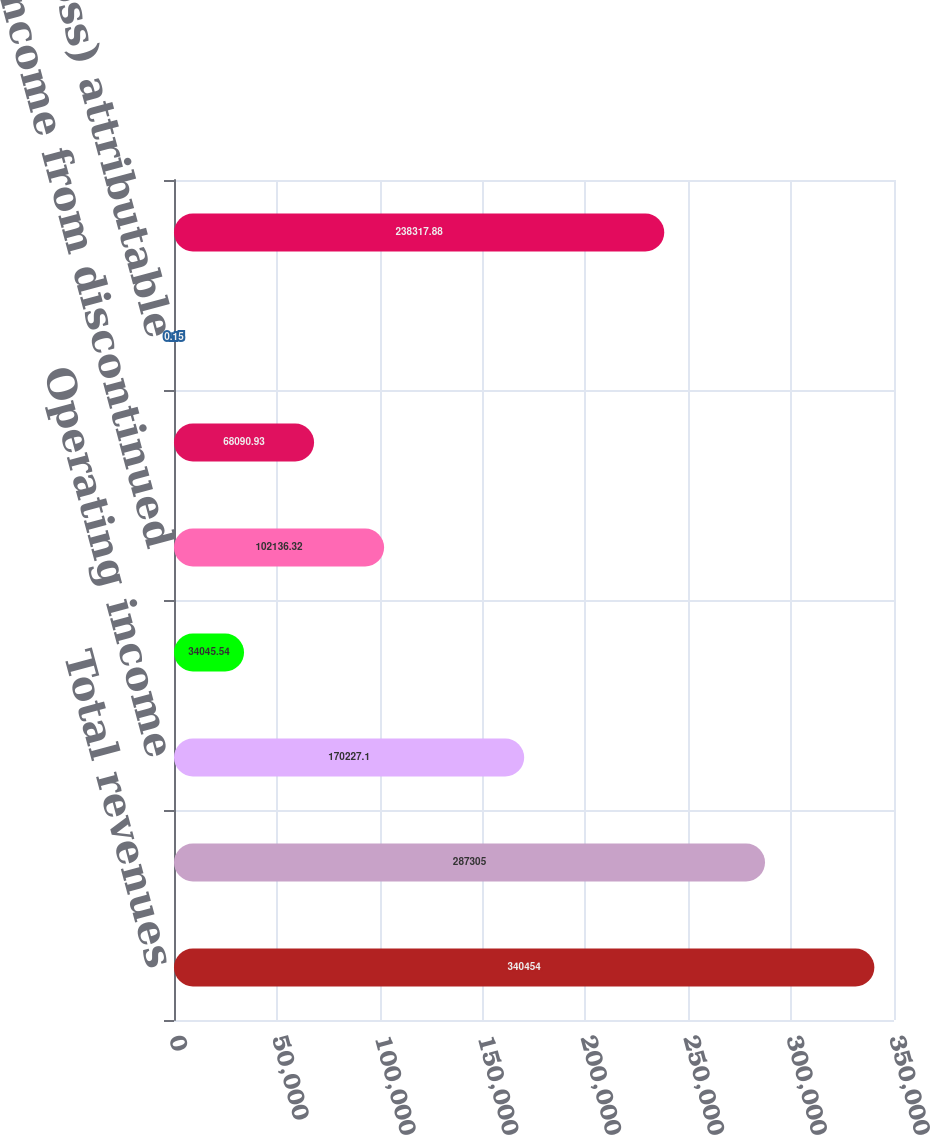Convert chart. <chart><loc_0><loc_0><loc_500><loc_500><bar_chart><fcel>Total revenues<fcel>Total operating expenses<fcel>Operating income<fcel>Loss from continuing<fcel>Income from discontinued<fcel>Net income (loss)<fcel>Net income (loss) attributable<fcel>Weighted average common shares<nl><fcel>340454<fcel>287305<fcel>170227<fcel>34045.5<fcel>102136<fcel>68090.9<fcel>0.15<fcel>238318<nl></chart> 